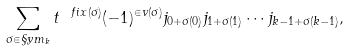Convert formula to latex. <formula><loc_0><loc_0><loc_500><loc_500>\sum _ { \sigma \in \S y m _ { k } } t ^ { \ f i x ( \sigma ) } ( - 1 ) ^ { \in v ( \sigma ) } j _ { 0 + \sigma ( 0 ) } j _ { 1 + \sigma ( 1 ) } \cdots j _ { k - 1 + \sigma ( k - 1 ) } ,</formula> 